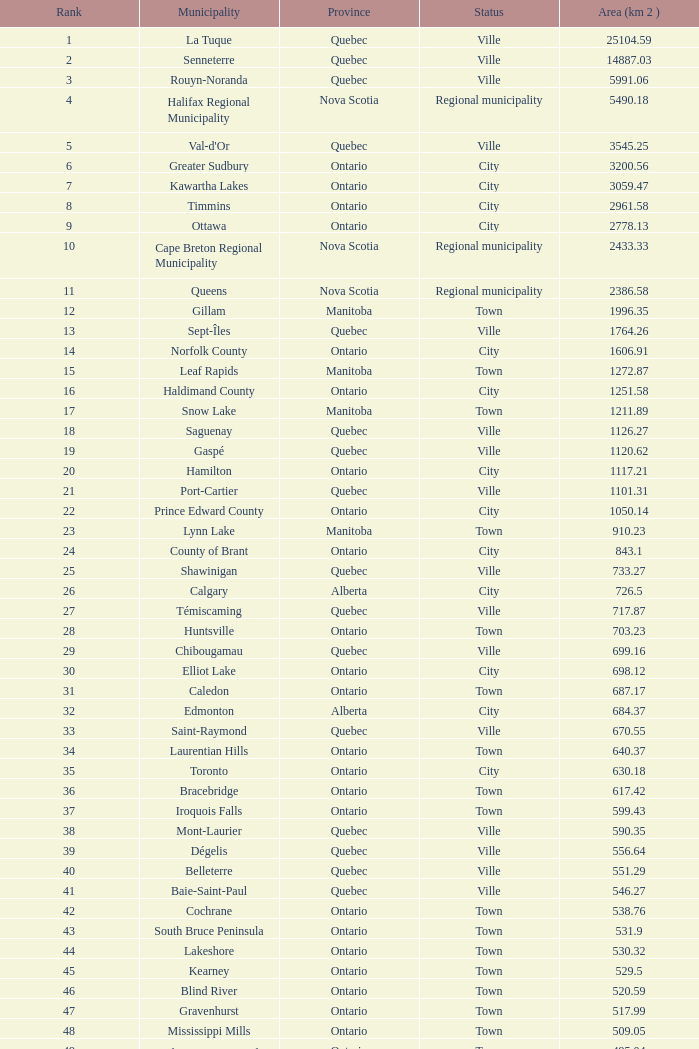What is the highest Area (KM 2) for the Province of Ontario, that has the Status of Town, a Municipality of Minto, and a Rank that's smaller than 84? None. 